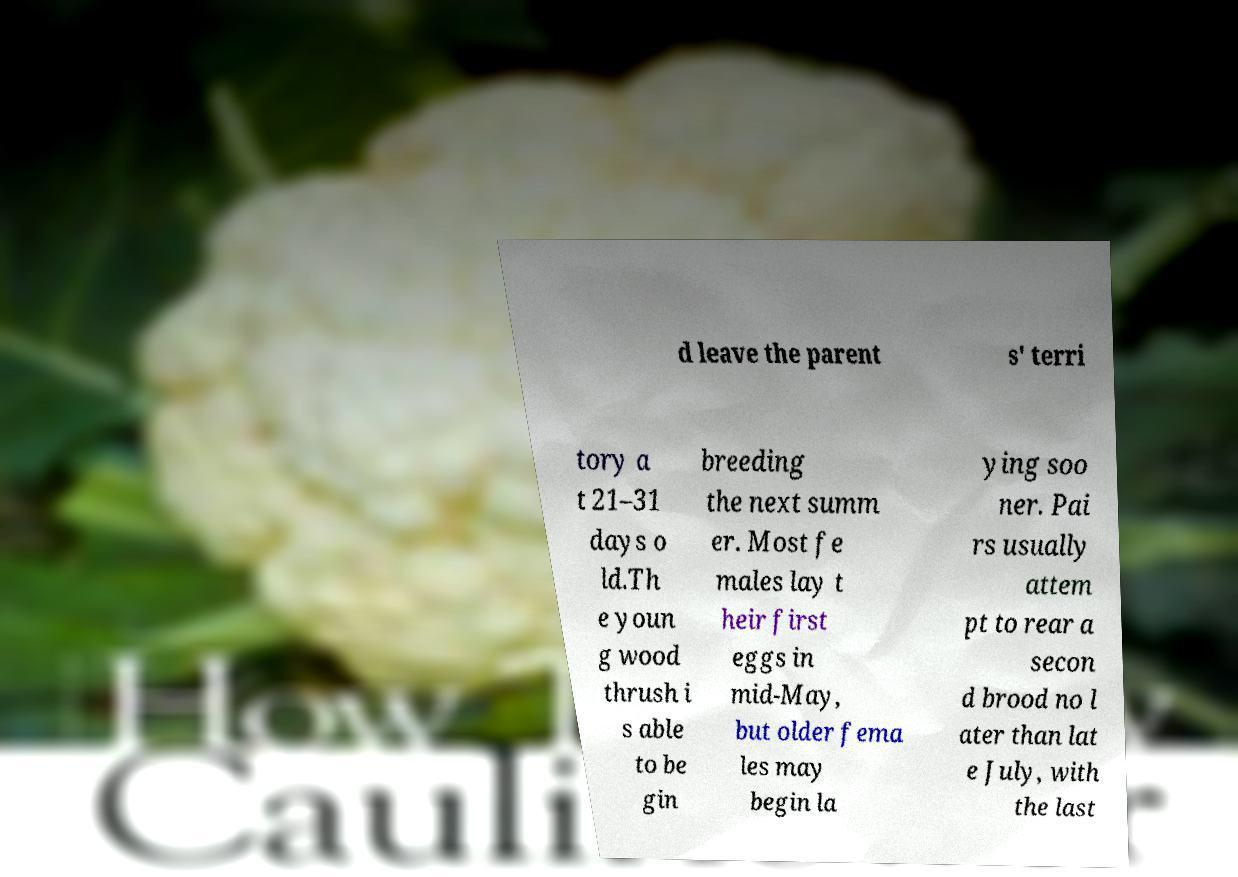Could you assist in decoding the text presented in this image and type it out clearly? d leave the parent s' terri tory a t 21–31 days o ld.Th e youn g wood thrush i s able to be gin breeding the next summ er. Most fe males lay t heir first eggs in mid-May, but older fema les may begin la ying soo ner. Pai rs usually attem pt to rear a secon d brood no l ater than lat e July, with the last 